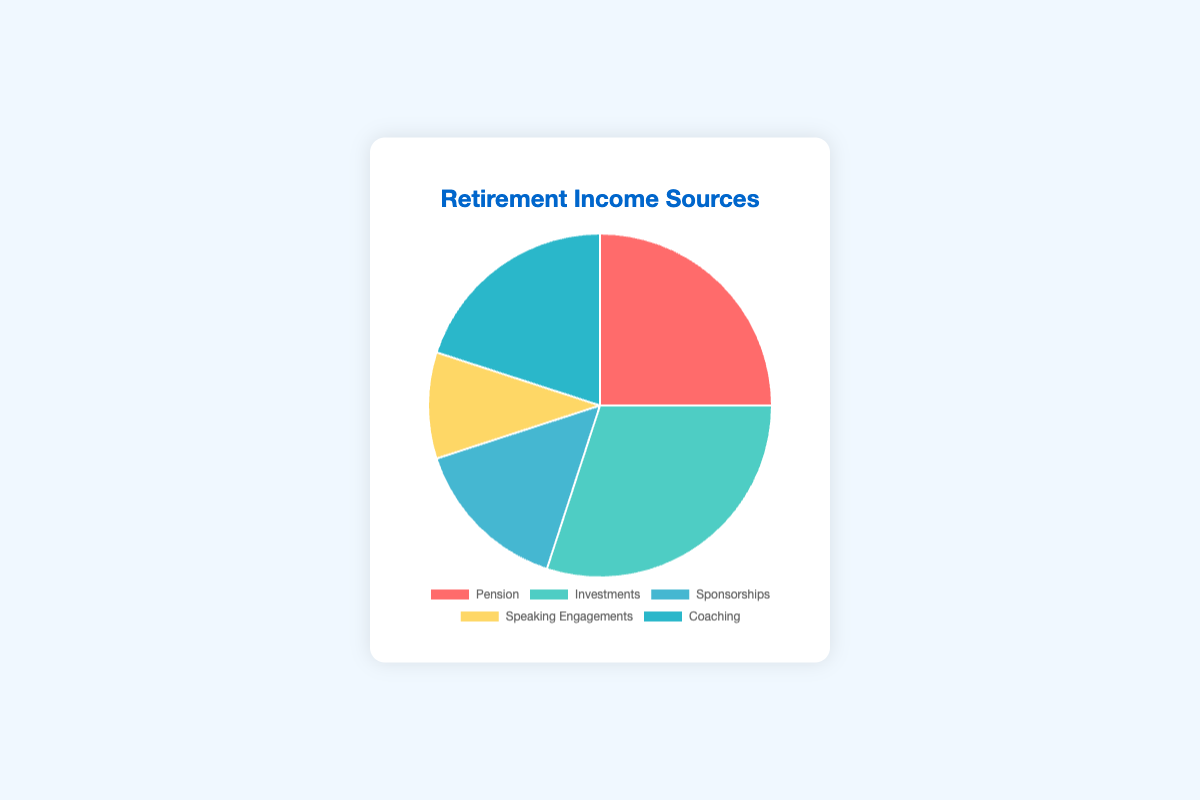Which source has the highest percentage of retirement income? By examining the pie chart, we can see that the segment representing "Investments" is the largest, indicating that Investments contribute the highest percentage to retirement income at 30%.
Answer: Investments Which source contributes more to retirement income, Sponsorships or Coaching? The chart shows that the percentage for Sponsorships is 15% and for Coaching is 20%. Since 20% is greater than 15%, Coaching contributes more to retirement income than Sponsorships.
Answer: Coaching What is the combined percentage for Pension and Speaking Engagements? From the chart, Pension contributes 25% and Speaking Engagements contribute 10%. Adding these together, 25% + 10% = 35%.
Answer: 35% Which income source is represented by the red color in the pie chart? By visually identifying the colors in the pie chart, we see that the segment colored red represents "Pension".
Answer: Pension Is the percentage of income from Coaching greater or less than the average percentage of all income sources? First calculate the average percentage: (25% + 30% + 15% + 10% + 20%) / 5 = 100% / 5 = 20%. The percentage from Coaching is 20%, which is equal to the average percentage.
Answer: Equal What is the difference in percentage between Pension and Sponsorships? The chart indicates that Pension's percentage is 25% and Sponsorships' percentage is 15%. The difference is 25% - 15% = 10%.
Answer: 10% Which two sources contribute equally to retirement income? By reviewing the data, we see that both Investments and Coaching contribute the same percentage: Investments at 30% and Pension at 20% each.
Answer: None What is the total percentage of retirement income from sources other than Investments? First, we sum the percentages of the other sources: Pension (25%) + Sponsorships (15%) + Speaking Engagements (10%) + Coaching (20%) = 25% + 15% + 10% + 20% = 70%.
Answer: 70% Which source has a percentage contribution exactly double that of Speaking Engagements? The percentage for Speaking Engagements is 10%. Double of 10% is 20%, which matches the percentage for Coaching.
Answer: Coaching 